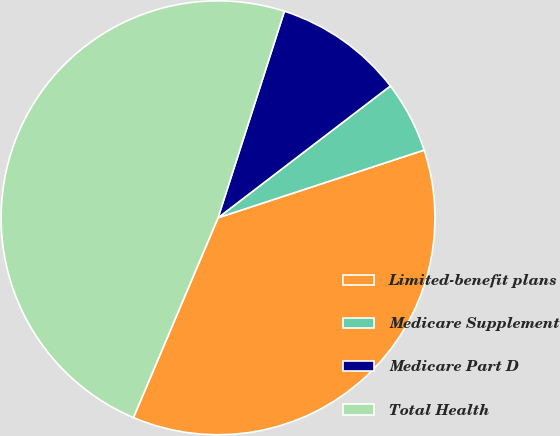Convert chart to OTSL. <chart><loc_0><loc_0><loc_500><loc_500><pie_chart><fcel>Limited-benefit plans<fcel>Medicare Supplement<fcel>Medicare Part D<fcel>Total Health<nl><fcel>36.43%<fcel>5.34%<fcel>9.66%<fcel>48.57%<nl></chart> 